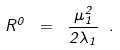<formula> <loc_0><loc_0><loc_500><loc_500>R ^ { 0 } \ = \ \frac { \mu _ { 1 } ^ { 2 } } { 2 \lambda _ { 1 } } \ .</formula> 